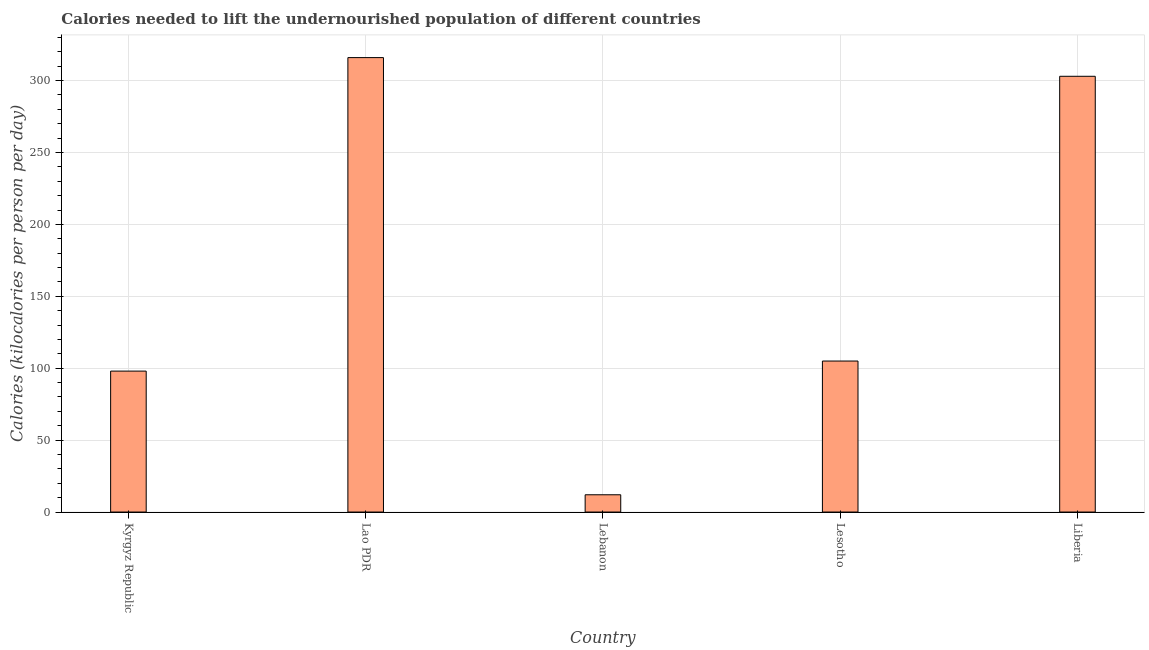What is the title of the graph?
Your answer should be very brief. Calories needed to lift the undernourished population of different countries. What is the label or title of the X-axis?
Offer a very short reply. Country. What is the label or title of the Y-axis?
Give a very brief answer. Calories (kilocalories per person per day). What is the depth of food deficit in Liberia?
Your answer should be compact. 303. Across all countries, what is the maximum depth of food deficit?
Your response must be concise. 316. In which country was the depth of food deficit maximum?
Ensure brevity in your answer.  Lao PDR. In which country was the depth of food deficit minimum?
Ensure brevity in your answer.  Lebanon. What is the sum of the depth of food deficit?
Provide a succinct answer. 834. What is the average depth of food deficit per country?
Keep it short and to the point. 166.8. What is the median depth of food deficit?
Your answer should be compact. 105. What is the ratio of the depth of food deficit in Kyrgyz Republic to that in Liberia?
Your answer should be very brief. 0.32. Is the depth of food deficit in Lao PDR less than that in Liberia?
Make the answer very short. No. Is the difference between the depth of food deficit in Lesotho and Liberia greater than the difference between any two countries?
Provide a short and direct response. No. Is the sum of the depth of food deficit in Kyrgyz Republic and Lebanon greater than the maximum depth of food deficit across all countries?
Give a very brief answer. No. What is the difference between the highest and the lowest depth of food deficit?
Provide a succinct answer. 304. In how many countries, is the depth of food deficit greater than the average depth of food deficit taken over all countries?
Offer a very short reply. 2. How many countries are there in the graph?
Provide a short and direct response. 5. What is the difference between two consecutive major ticks on the Y-axis?
Offer a terse response. 50. Are the values on the major ticks of Y-axis written in scientific E-notation?
Give a very brief answer. No. What is the Calories (kilocalories per person per day) of Kyrgyz Republic?
Keep it short and to the point. 98. What is the Calories (kilocalories per person per day) of Lao PDR?
Keep it short and to the point. 316. What is the Calories (kilocalories per person per day) in Lebanon?
Your response must be concise. 12. What is the Calories (kilocalories per person per day) in Lesotho?
Give a very brief answer. 105. What is the Calories (kilocalories per person per day) of Liberia?
Ensure brevity in your answer.  303. What is the difference between the Calories (kilocalories per person per day) in Kyrgyz Republic and Lao PDR?
Your answer should be very brief. -218. What is the difference between the Calories (kilocalories per person per day) in Kyrgyz Republic and Liberia?
Your answer should be compact. -205. What is the difference between the Calories (kilocalories per person per day) in Lao PDR and Lebanon?
Offer a very short reply. 304. What is the difference between the Calories (kilocalories per person per day) in Lao PDR and Lesotho?
Make the answer very short. 211. What is the difference between the Calories (kilocalories per person per day) in Lebanon and Lesotho?
Your answer should be very brief. -93. What is the difference between the Calories (kilocalories per person per day) in Lebanon and Liberia?
Provide a succinct answer. -291. What is the difference between the Calories (kilocalories per person per day) in Lesotho and Liberia?
Your answer should be compact. -198. What is the ratio of the Calories (kilocalories per person per day) in Kyrgyz Republic to that in Lao PDR?
Provide a short and direct response. 0.31. What is the ratio of the Calories (kilocalories per person per day) in Kyrgyz Republic to that in Lebanon?
Your response must be concise. 8.17. What is the ratio of the Calories (kilocalories per person per day) in Kyrgyz Republic to that in Lesotho?
Provide a succinct answer. 0.93. What is the ratio of the Calories (kilocalories per person per day) in Kyrgyz Republic to that in Liberia?
Offer a terse response. 0.32. What is the ratio of the Calories (kilocalories per person per day) in Lao PDR to that in Lebanon?
Your answer should be very brief. 26.33. What is the ratio of the Calories (kilocalories per person per day) in Lao PDR to that in Lesotho?
Give a very brief answer. 3.01. What is the ratio of the Calories (kilocalories per person per day) in Lao PDR to that in Liberia?
Give a very brief answer. 1.04. What is the ratio of the Calories (kilocalories per person per day) in Lebanon to that in Lesotho?
Your answer should be very brief. 0.11. What is the ratio of the Calories (kilocalories per person per day) in Lebanon to that in Liberia?
Ensure brevity in your answer.  0.04. What is the ratio of the Calories (kilocalories per person per day) in Lesotho to that in Liberia?
Make the answer very short. 0.35. 